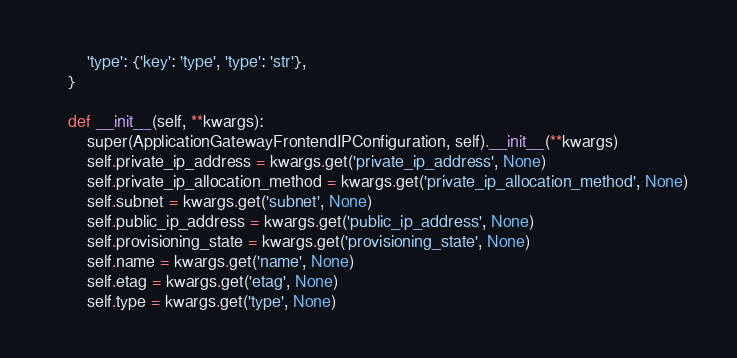<code> <loc_0><loc_0><loc_500><loc_500><_Python_>        'type': {'key': 'type', 'type': 'str'},
    }

    def __init__(self, **kwargs):
        super(ApplicationGatewayFrontendIPConfiguration, self).__init__(**kwargs)
        self.private_ip_address = kwargs.get('private_ip_address', None)
        self.private_ip_allocation_method = kwargs.get('private_ip_allocation_method', None)
        self.subnet = kwargs.get('subnet', None)
        self.public_ip_address = kwargs.get('public_ip_address', None)
        self.provisioning_state = kwargs.get('provisioning_state', None)
        self.name = kwargs.get('name', None)
        self.etag = kwargs.get('etag', None)
        self.type = kwargs.get('type', None)
</code> 